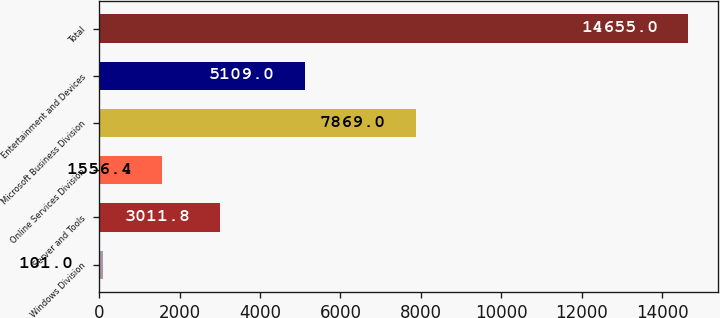Convert chart. <chart><loc_0><loc_0><loc_500><loc_500><bar_chart><fcel>Windows Division<fcel>Server and Tools<fcel>Online Services Division<fcel>Microsoft Business Division<fcel>Entertainment and Devices<fcel>Total<nl><fcel>101<fcel>3011.8<fcel>1556.4<fcel>7869<fcel>5109<fcel>14655<nl></chart> 